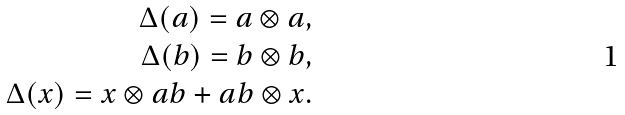<formula> <loc_0><loc_0><loc_500><loc_500>\Delta ( a ) = a \otimes a , \\ \Delta ( b ) = b \otimes b , \\ \Delta ( x ) = x \otimes a b + a b \otimes x .</formula> 